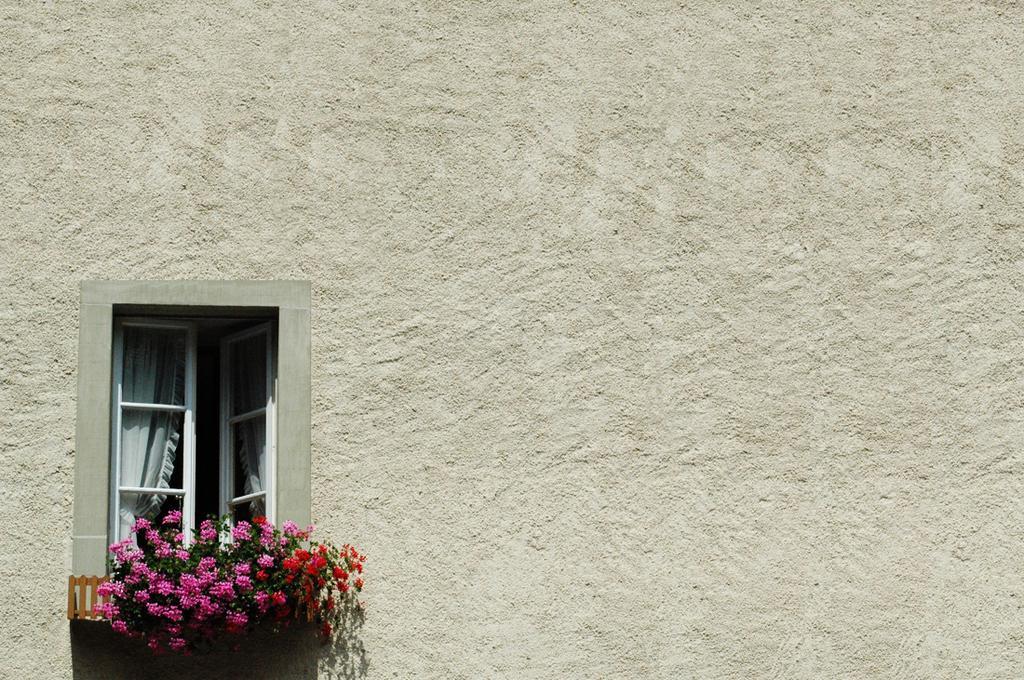Can you describe this image briefly? In this image we can see window doors, curtains and plants with flowers at the window. 